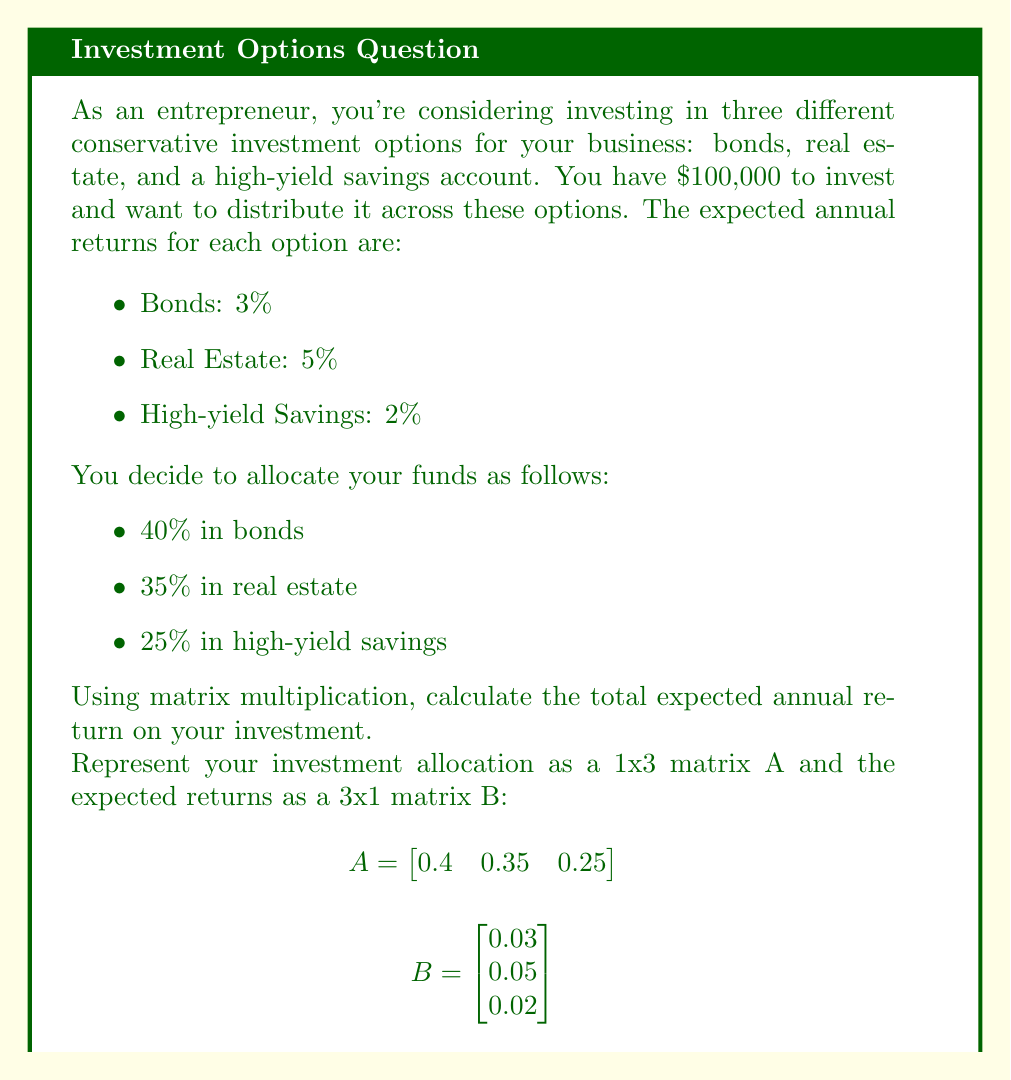Can you solve this math problem? To solve this problem, we need to perform matrix multiplication of A and B. The resulting 1x1 matrix will give us the weighted average of the returns, which is our expected total return.

Step 1: Set up the matrix multiplication
$$ C = A \times B = \begin{bmatrix} 0.4 & 0.35 & 0.25 \end{bmatrix} \times \begin{bmatrix} 0.03 \\ 0.05 \\ 0.02 \end{bmatrix} $$

Step 2: Multiply each element of A with the corresponding element of B and sum the results
$$ C = (0.4 \times 0.03) + (0.35 \times 0.05) + (0.25 \times 0.02) $$

Step 3: Calculate each term
$$ C = 0.012 + 0.0175 + 0.005 $$

Step 4: Sum up the terms
$$ C = 0.0345 $$

Step 5: Convert to percentage
The result 0.0345 represents a 3.45% expected annual return on your investment.

To calculate the actual dollar amount of the return:
$$ \text{Return} = \$100,000 \times 0.0345 = \$3,450 $$
Answer: 3.45% or $3,450 